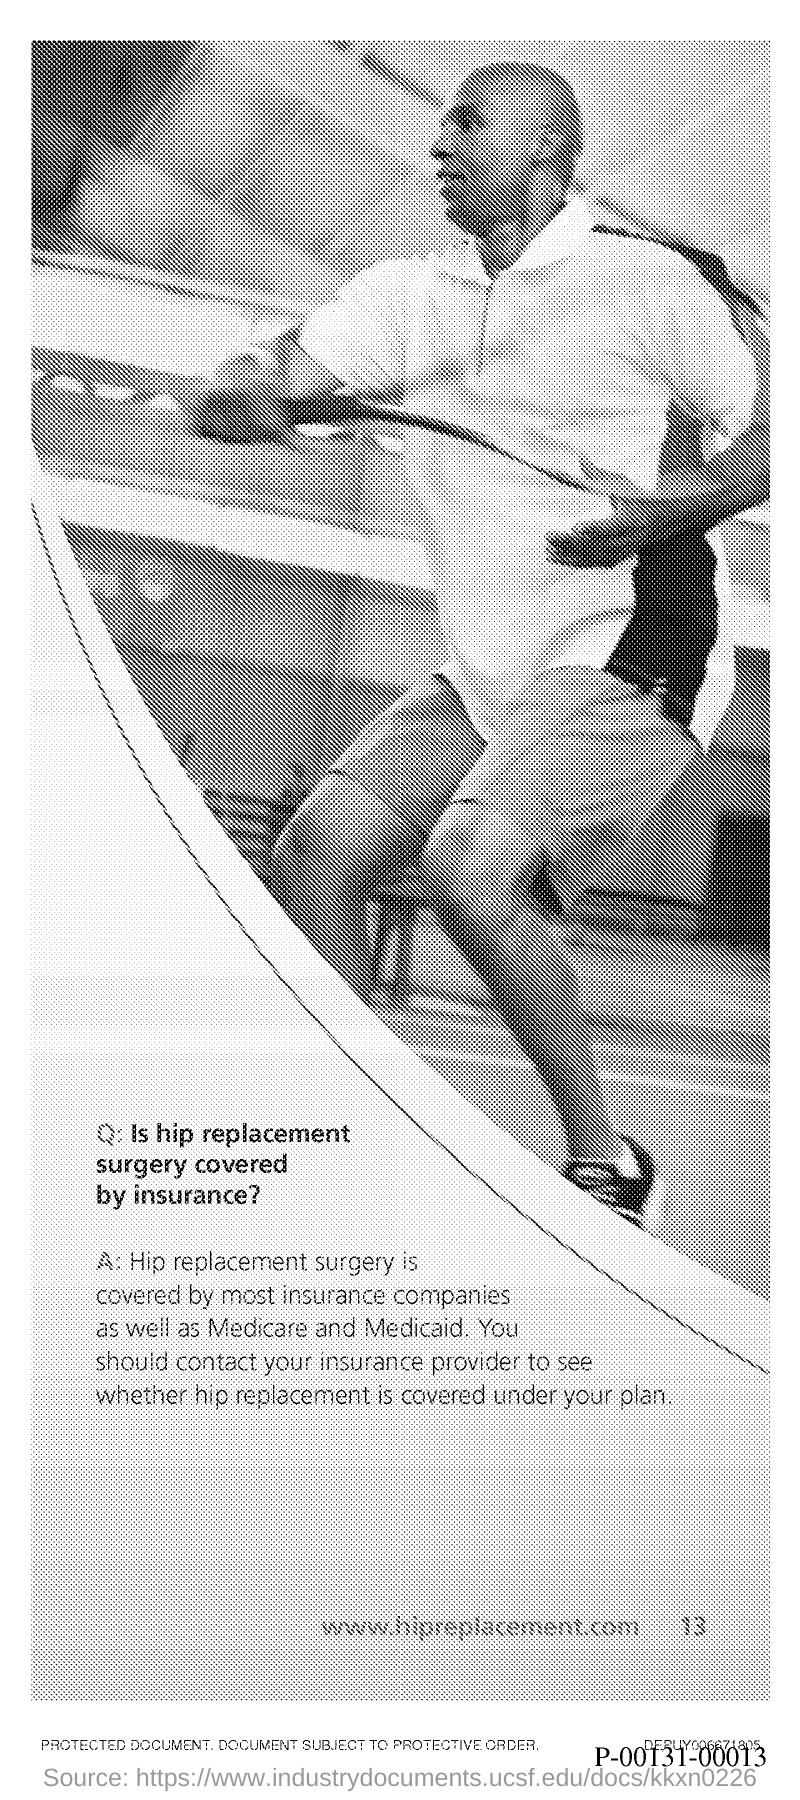Highlight a few significant elements in this photo. The page number is 13. At the website located at [www.hipreplacement.com](http://www.hipreplacement.com), there is a document that provides information about hip replacement surgery. 